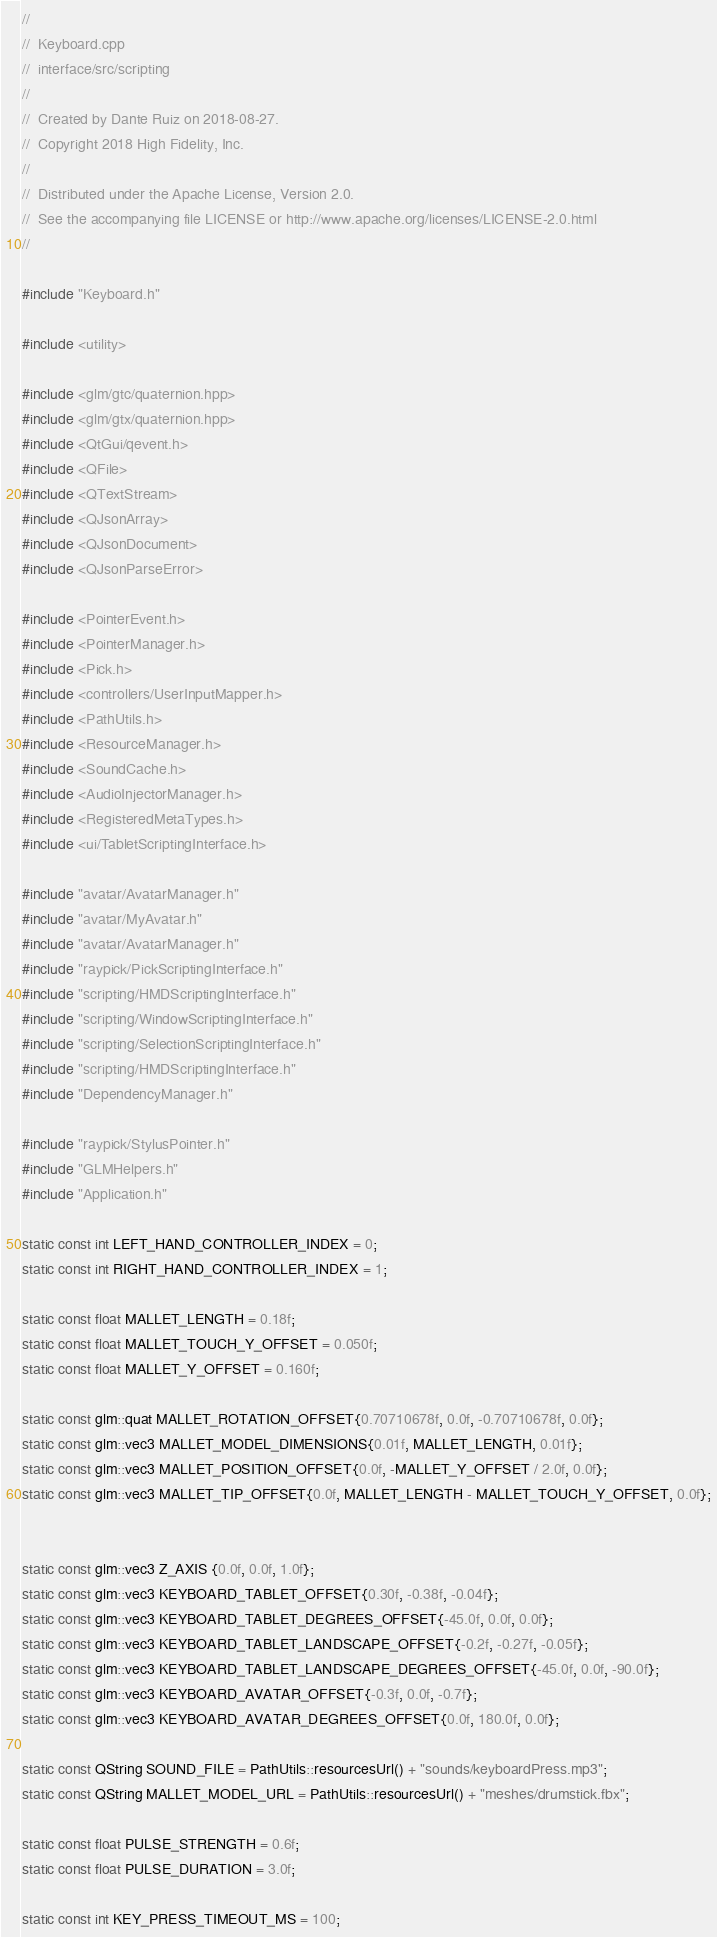<code> <loc_0><loc_0><loc_500><loc_500><_C++_>//
//  Keyboard.cpp
//  interface/src/scripting
//
//  Created by Dante Ruiz on 2018-08-27.
//  Copyright 2018 High Fidelity, Inc.
//
//  Distributed under the Apache License, Version 2.0.
//  See the accompanying file LICENSE or http://www.apache.org/licenses/LICENSE-2.0.html
//

#include "Keyboard.h"

#include <utility>

#include <glm/gtc/quaternion.hpp>
#include <glm/gtx/quaternion.hpp>
#include <QtGui/qevent.h>
#include <QFile>
#include <QTextStream>
#include <QJsonArray>
#include <QJsonDocument>
#include <QJsonParseError>

#include <PointerEvent.h>
#include <PointerManager.h>
#include <Pick.h>
#include <controllers/UserInputMapper.h>
#include <PathUtils.h>
#include <ResourceManager.h>
#include <SoundCache.h>
#include <AudioInjectorManager.h>
#include <RegisteredMetaTypes.h>
#include <ui/TabletScriptingInterface.h>

#include "avatar/AvatarManager.h"
#include "avatar/MyAvatar.h"
#include "avatar/AvatarManager.h"
#include "raypick/PickScriptingInterface.h"
#include "scripting/HMDScriptingInterface.h"
#include "scripting/WindowScriptingInterface.h"
#include "scripting/SelectionScriptingInterface.h"
#include "scripting/HMDScriptingInterface.h"
#include "DependencyManager.h"

#include "raypick/StylusPointer.h"
#include "GLMHelpers.h"
#include "Application.h"

static const int LEFT_HAND_CONTROLLER_INDEX = 0;
static const int RIGHT_HAND_CONTROLLER_INDEX = 1;

static const float MALLET_LENGTH = 0.18f;
static const float MALLET_TOUCH_Y_OFFSET = 0.050f;
static const float MALLET_Y_OFFSET = 0.160f;

static const glm::quat MALLET_ROTATION_OFFSET{0.70710678f, 0.0f, -0.70710678f, 0.0f};
static const glm::vec3 MALLET_MODEL_DIMENSIONS{0.01f, MALLET_LENGTH, 0.01f};
static const glm::vec3 MALLET_POSITION_OFFSET{0.0f, -MALLET_Y_OFFSET / 2.0f, 0.0f};
static const glm::vec3 MALLET_TIP_OFFSET{0.0f, MALLET_LENGTH - MALLET_TOUCH_Y_OFFSET, 0.0f};


static const glm::vec3 Z_AXIS {0.0f, 0.0f, 1.0f};
static const glm::vec3 KEYBOARD_TABLET_OFFSET{0.30f, -0.38f, -0.04f};
static const glm::vec3 KEYBOARD_TABLET_DEGREES_OFFSET{-45.0f, 0.0f, 0.0f};
static const glm::vec3 KEYBOARD_TABLET_LANDSCAPE_OFFSET{-0.2f, -0.27f, -0.05f};
static const glm::vec3 KEYBOARD_TABLET_LANDSCAPE_DEGREES_OFFSET{-45.0f, 0.0f, -90.0f};
static const glm::vec3 KEYBOARD_AVATAR_OFFSET{-0.3f, 0.0f, -0.7f};
static const glm::vec3 KEYBOARD_AVATAR_DEGREES_OFFSET{0.0f, 180.0f, 0.0f};

static const QString SOUND_FILE = PathUtils::resourcesUrl() + "sounds/keyboardPress.mp3";
static const QString MALLET_MODEL_URL = PathUtils::resourcesUrl() + "meshes/drumstick.fbx";

static const float PULSE_STRENGTH = 0.6f;
static const float PULSE_DURATION = 3.0f;

static const int KEY_PRESS_TIMEOUT_MS = 100;</code> 